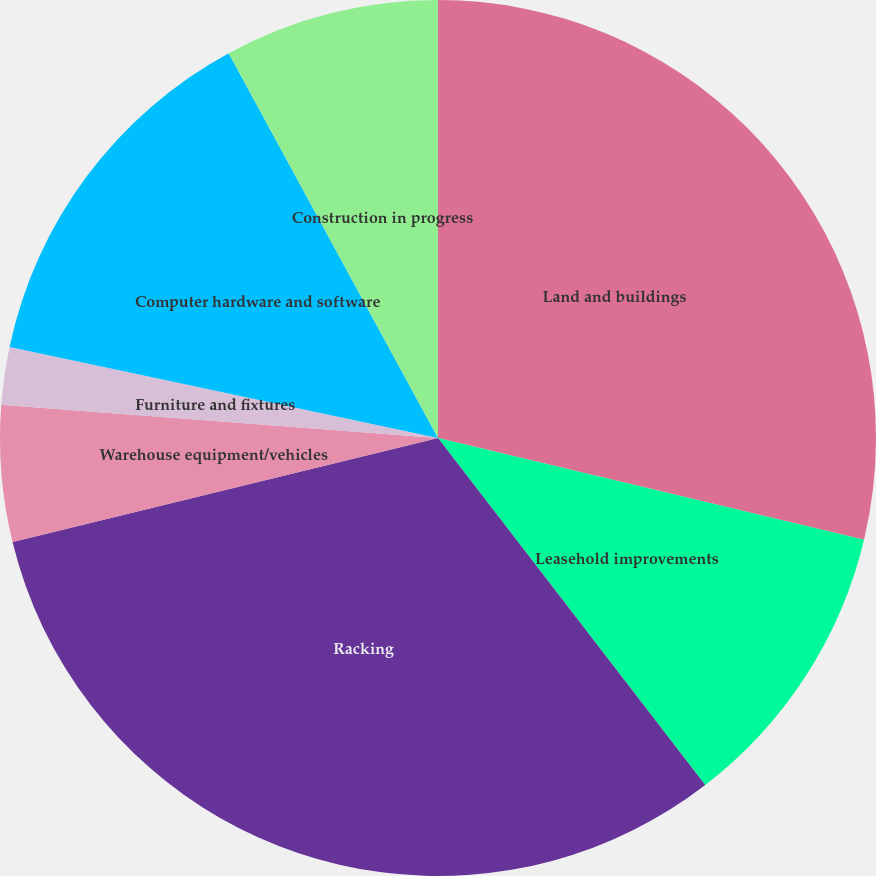<chart> <loc_0><loc_0><loc_500><loc_500><pie_chart><fcel>Land and buildings<fcel>Leasehold improvements<fcel>Racking<fcel>Warehouse equipment/vehicles<fcel>Furniture and fixtures<fcel>Computer hardware and software<fcel>Construction in progress<nl><fcel>28.73%<fcel>10.83%<fcel>31.63%<fcel>5.03%<fcel>2.12%<fcel>13.74%<fcel>7.93%<nl></chart> 